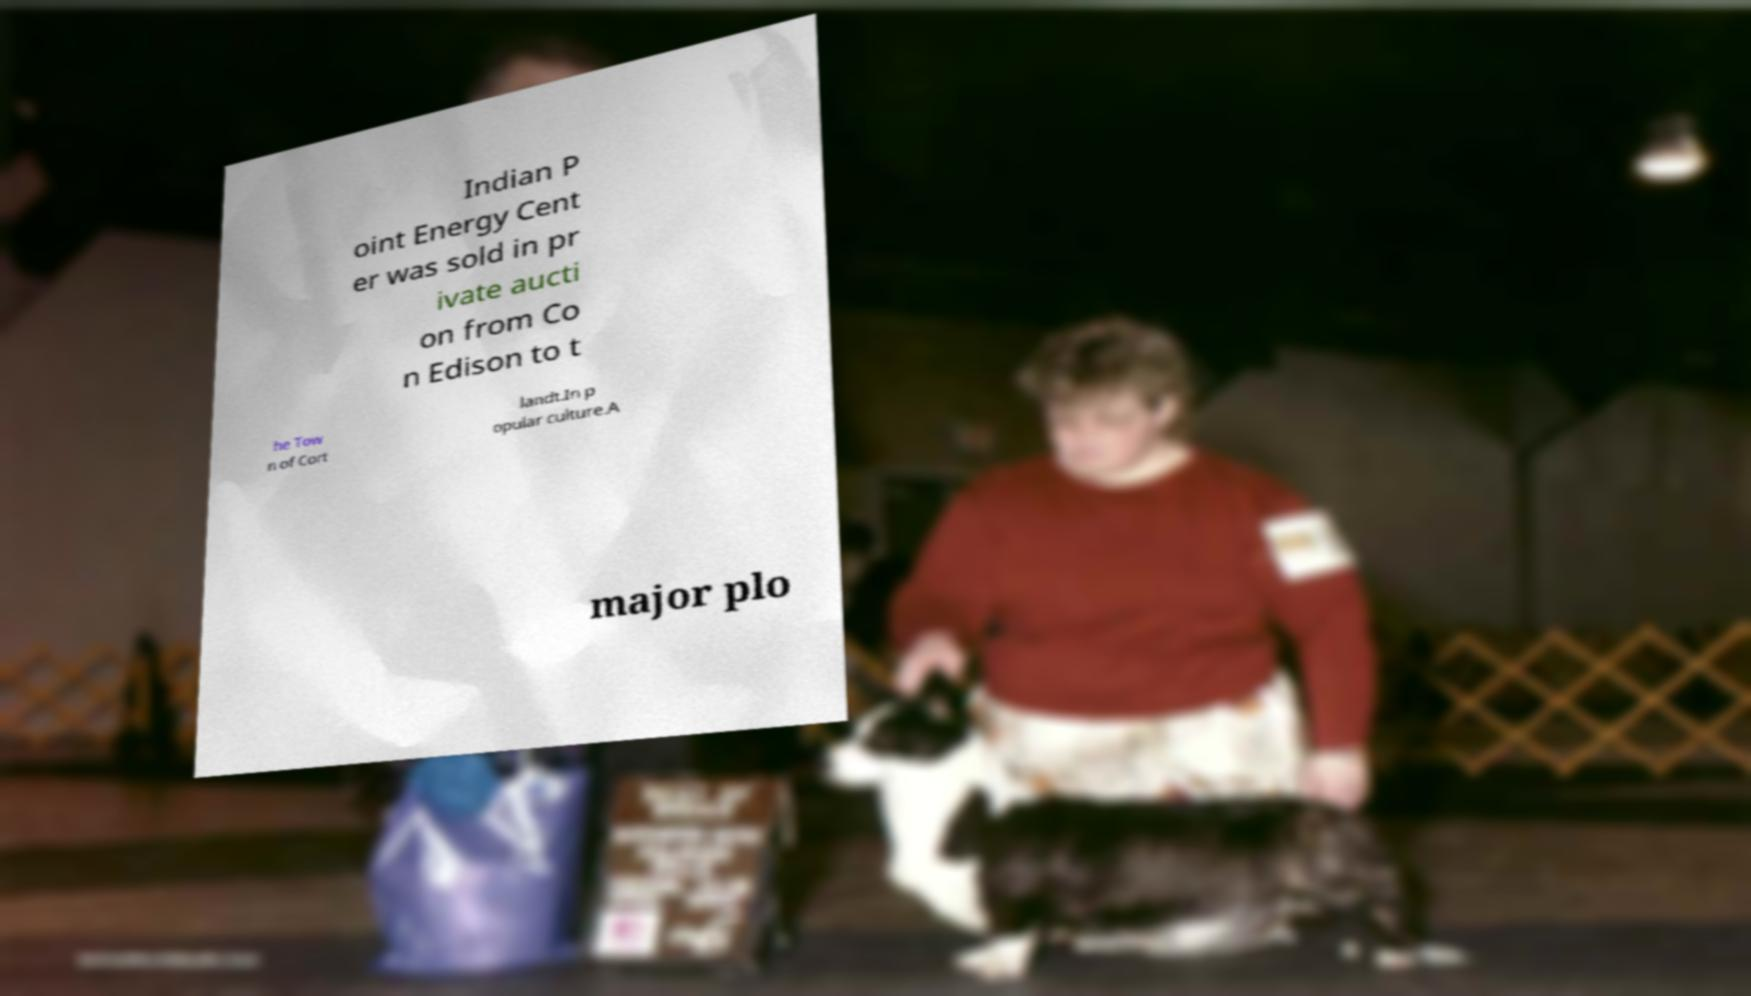What messages or text are displayed in this image? I need them in a readable, typed format. Indian P oint Energy Cent er was sold in pr ivate aucti on from Co n Edison to t he Tow n of Cort landt.In p opular culture.A major plo 